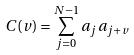<formula> <loc_0><loc_0><loc_500><loc_500>C ( v ) = \sum _ { j = 0 } ^ { N - 1 } a _ { j } a _ { j + v }</formula> 